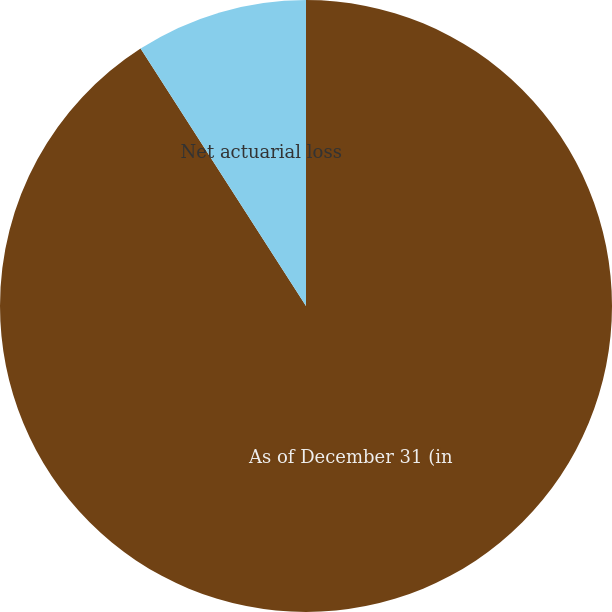Convert chart to OTSL. <chart><loc_0><loc_0><loc_500><loc_500><pie_chart><fcel>As of December 31 (in<fcel>Net actuarial loss<fcel>Total pre-tax amounts included<nl><fcel>90.9%<fcel>9.09%<fcel>0.0%<nl></chart> 